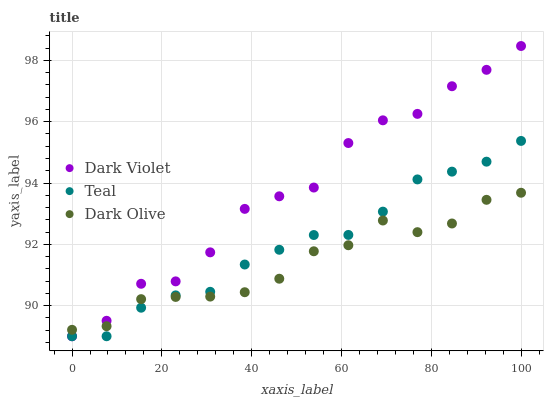Does Dark Olive have the minimum area under the curve?
Answer yes or no. Yes. Does Dark Violet have the maximum area under the curve?
Answer yes or no. Yes. Does Teal have the minimum area under the curve?
Answer yes or no. No. Does Teal have the maximum area under the curve?
Answer yes or no. No. Is Teal the smoothest?
Answer yes or no. Yes. Is Dark Violet the roughest?
Answer yes or no. Yes. Is Dark Violet the smoothest?
Answer yes or no. No. Is Teal the roughest?
Answer yes or no. No. Does Teal have the lowest value?
Answer yes or no. Yes. Does Dark Violet have the highest value?
Answer yes or no. Yes. Does Teal have the highest value?
Answer yes or no. No. Does Dark Violet intersect Teal?
Answer yes or no. Yes. Is Dark Violet less than Teal?
Answer yes or no. No. Is Dark Violet greater than Teal?
Answer yes or no. No. 